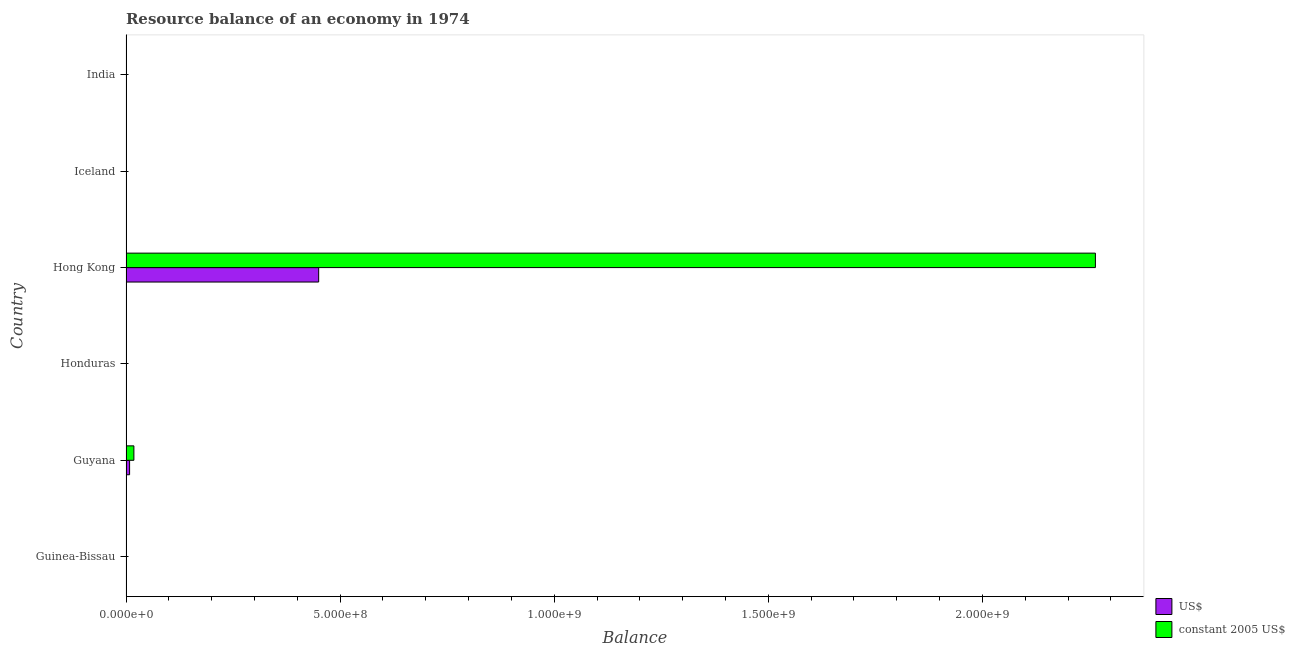Are the number of bars per tick equal to the number of legend labels?
Keep it short and to the point. No. What is the label of the 5th group of bars from the top?
Make the answer very short. Guyana. What is the resource balance in us$ in Guyana?
Offer a terse response. 8.36e+06. Across all countries, what is the maximum resource balance in constant us$?
Keep it short and to the point. 2.26e+09. Across all countries, what is the minimum resource balance in constant us$?
Provide a short and direct response. 0. In which country was the resource balance in us$ maximum?
Your answer should be very brief. Hong Kong. What is the total resource balance in constant us$ in the graph?
Your answer should be compact. 2.28e+09. What is the difference between the resource balance in us$ in Honduras and the resource balance in constant us$ in Hong Kong?
Make the answer very short. -2.26e+09. What is the average resource balance in us$ per country?
Keep it short and to the point. 7.64e+07. What is the difference between the resource balance in constant us$ and resource balance in us$ in Guyana?
Offer a very short reply. 1.00e+07. What is the difference between the highest and the lowest resource balance in constant us$?
Ensure brevity in your answer.  2.26e+09. What is the difference between two consecutive major ticks on the X-axis?
Your answer should be very brief. 5.00e+08. Are the values on the major ticks of X-axis written in scientific E-notation?
Offer a terse response. Yes. Where does the legend appear in the graph?
Your response must be concise. Bottom right. How are the legend labels stacked?
Make the answer very short. Vertical. What is the title of the graph?
Offer a terse response. Resource balance of an economy in 1974. Does "Public funds" appear as one of the legend labels in the graph?
Your answer should be compact. No. What is the label or title of the X-axis?
Your answer should be very brief. Balance. What is the Balance in US$ in Guinea-Bissau?
Your response must be concise. 0. What is the Balance of US$ in Guyana?
Make the answer very short. 8.36e+06. What is the Balance in constant 2005 US$ in Guyana?
Your answer should be compact. 1.84e+07. What is the Balance in US$ in Honduras?
Provide a succinct answer. 0. What is the Balance of constant 2005 US$ in Honduras?
Your answer should be very brief. 0. What is the Balance in US$ in Hong Kong?
Your answer should be very brief. 4.50e+08. What is the Balance of constant 2005 US$ in Hong Kong?
Keep it short and to the point. 2.26e+09. Across all countries, what is the maximum Balance in US$?
Offer a terse response. 4.50e+08. Across all countries, what is the maximum Balance of constant 2005 US$?
Your answer should be very brief. 2.26e+09. Across all countries, what is the minimum Balance in constant 2005 US$?
Offer a terse response. 0. What is the total Balance of US$ in the graph?
Make the answer very short. 4.58e+08. What is the total Balance in constant 2005 US$ in the graph?
Keep it short and to the point. 2.28e+09. What is the difference between the Balance in US$ in Guyana and that in Hong Kong?
Offer a terse response. -4.42e+08. What is the difference between the Balance in constant 2005 US$ in Guyana and that in Hong Kong?
Keep it short and to the point. -2.25e+09. What is the difference between the Balance of US$ in Guyana and the Balance of constant 2005 US$ in Hong Kong?
Give a very brief answer. -2.26e+09. What is the average Balance in US$ per country?
Ensure brevity in your answer.  7.64e+07. What is the average Balance in constant 2005 US$ per country?
Your answer should be very brief. 3.80e+08. What is the difference between the Balance in US$ and Balance in constant 2005 US$ in Guyana?
Your response must be concise. -1.00e+07. What is the difference between the Balance in US$ and Balance in constant 2005 US$ in Hong Kong?
Ensure brevity in your answer.  -1.81e+09. What is the ratio of the Balance of US$ in Guyana to that in Hong Kong?
Keep it short and to the point. 0.02. What is the ratio of the Balance of constant 2005 US$ in Guyana to that in Hong Kong?
Offer a terse response. 0.01. What is the difference between the highest and the lowest Balance in US$?
Provide a succinct answer. 4.50e+08. What is the difference between the highest and the lowest Balance of constant 2005 US$?
Give a very brief answer. 2.26e+09. 